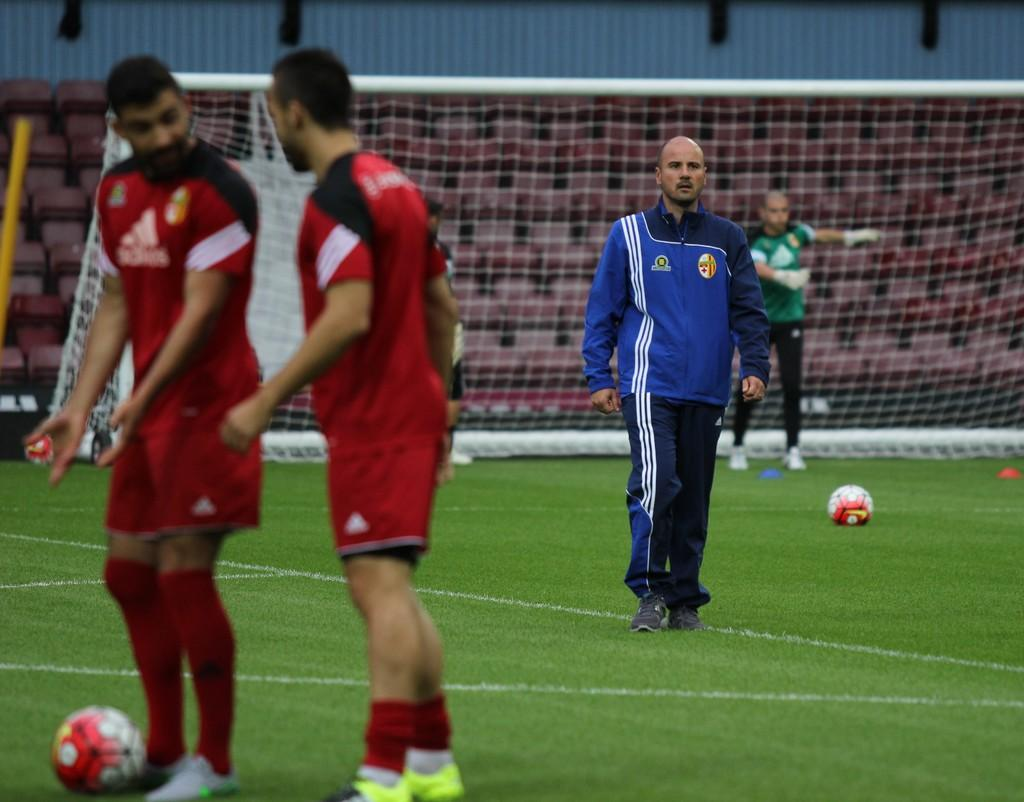What type of sports facility is shown in the image? The image depicts a football ground. What can be seen on the football ground? There are players standing on the ground. How many balls are present on the ground? There are two balls on the ground. What is the condition of the stadium behind the football ground? The stadium behind the ground is empty. What type of sheet is covering the players on the football ground? There is no sheet covering the players on the football ground in the image. How many deaths have occurred during the game depicted in the image? There is no indication of any deaths occurring during the game depicted in the image. 